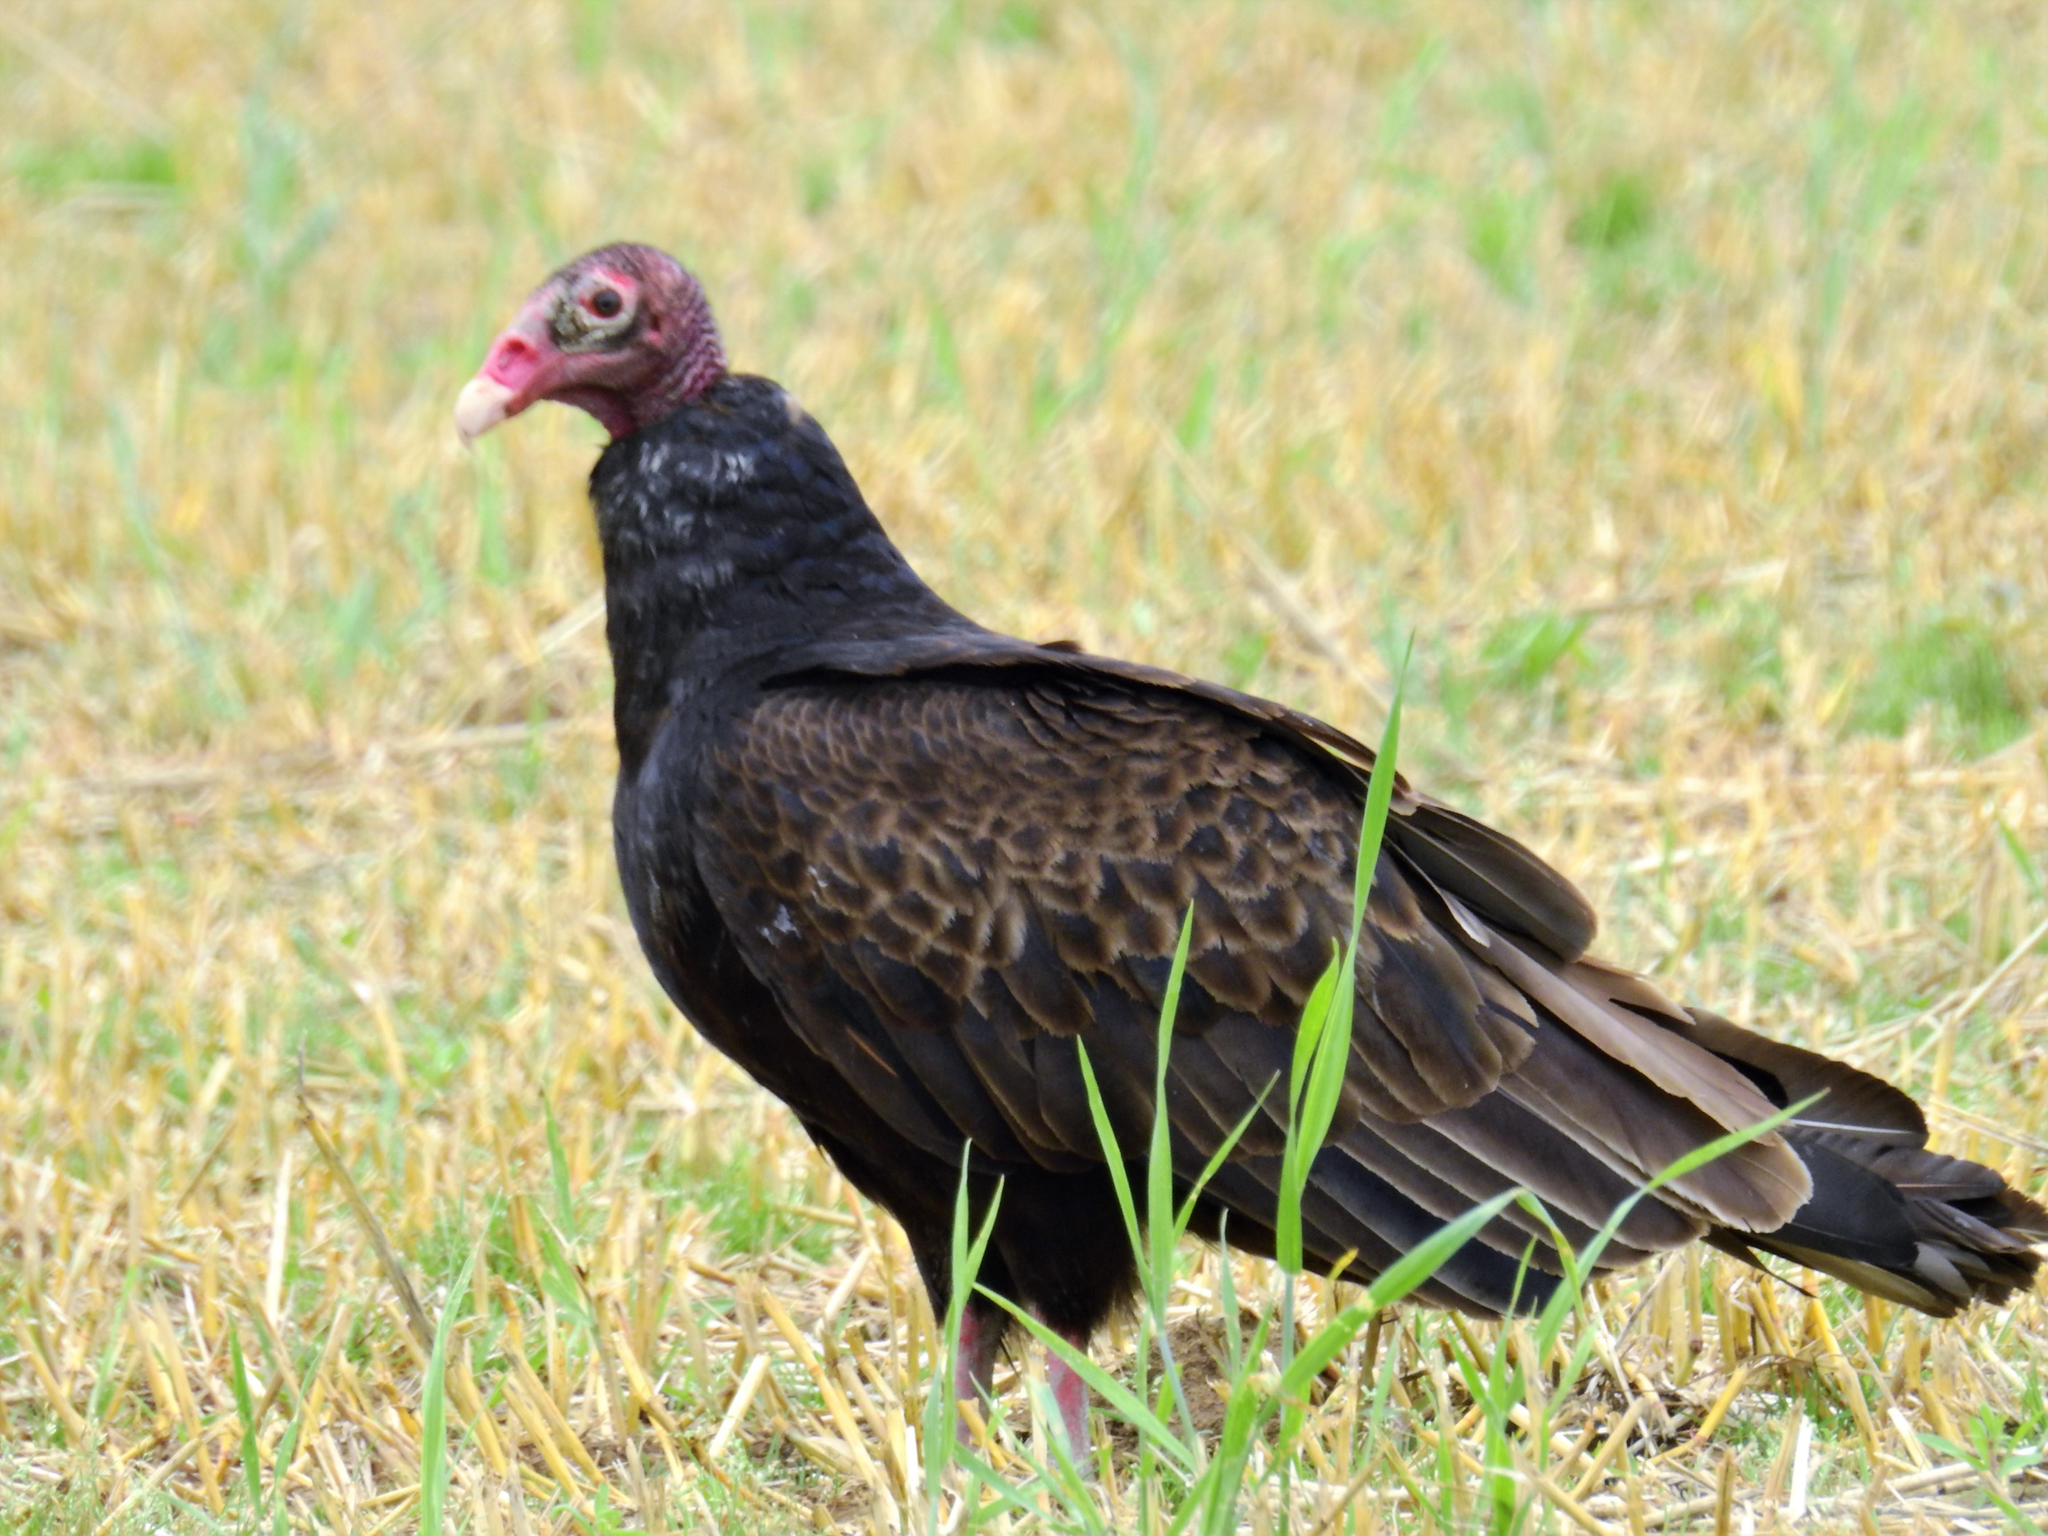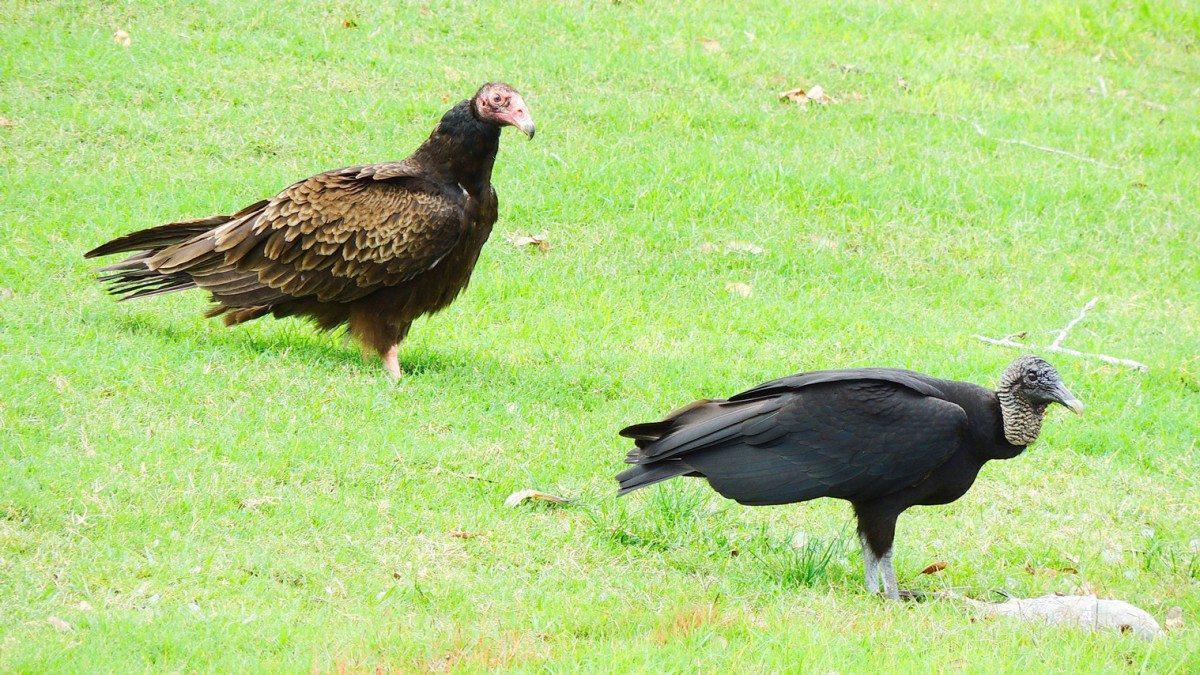The first image is the image on the left, the second image is the image on the right. Evaluate the accuracy of this statement regarding the images: "A total of three vultures are shown.". Is it true? Answer yes or no. Yes. 